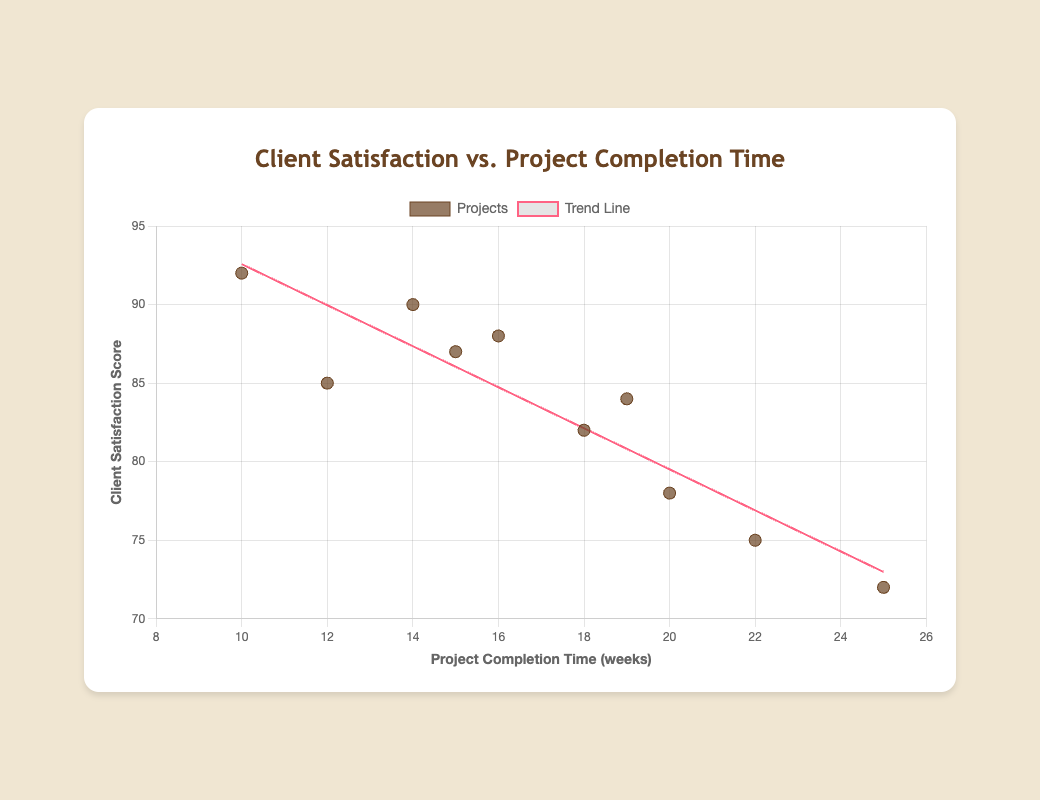What is the title of the chart? The title is usually displayed at the top of the chart, indicating the main subject or data being visualized. In this case, the title is "Client Satisfaction vs. Project Completion Time".
Answer: Client Satisfaction vs. Project Completion Time How many data points are there in the chart? Count the number of individual points plotted on the scatter plot. Each point represents one project. According to the data, there are 10 projects plotted on the scatter chart.
Answer: 10 What is the range of completion times for the projects? To find the range, identify the smallest and largest values on the x-axis, which represents completion times in weeks. The smallest value is 10 (Willow Lane Estate) and the largest is 25 (Sycamore Summit). So, the range is 10 to 25 weeks.
Answer: 10 to 25 weeks Which project has the highest client satisfaction score? Look for the highest point on the y-axis, representing client satisfaction scores. The highest score is 92, corresponding to Willow Lane Estate.
Answer: Willow Lane Estate Is there a visible trend in the relationship between project completion time and client satisfaction score? Observe the trend line drawn through the scatter plot. The trend line may indicate whether there is an increase, decrease, or no clear relationship. Here, the trend line suggests a slight decrease in satisfaction scores as completion time increases.
Answer: Slight decrease Which project took the longest to complete and what was its client satisfaction score? Identify the data point farthest to the right on the x-axis (completion time). The longest completion time is 25 weeks for Sycamore Summit, with a satisfaction score of 72.
Answer: Sycamore Summit, 72 What is the approximate slope of the trend line? The slope can be inferred from the linear regression equation given or visually estimated from the trend line's rise over run. From the data, the trend appears to slightly decrease linearly; exact values from code indicate a negative slope.
Answer: Negative slope How does the client satisfaction score of Elm Avenue House compare to that of Aspen Heights? Find both points on the scatter plot and compare their vertical positions. Elm Avenue House has a satisfaction score of 82, while Aspen Heights has a score of 84, making Aspen Heights' score slightly higher.
Answer: Aspen Heights is higher What is the average client satisfaction score for all the projects? Sum all the satisfaction scores and divide by the number of projects. The scores are 85, 78, 90, 82, 75, 88, 92, 72, 87, 84. The sum is 833, and the average is 833/10 = 83.3.
Answer: 83.3 Which project has a completion time closest to the average completion time of all projects? Calculate the average completion time: (12 + 20 + 14 + 18 + 22 + 16 + 10 + 25 + 15 + 19) / 10 = 17.1 weeks. The project with the closest completion time to this average is Elm Avenue House at 18 weeks.
Answer: Elm Avenue House 